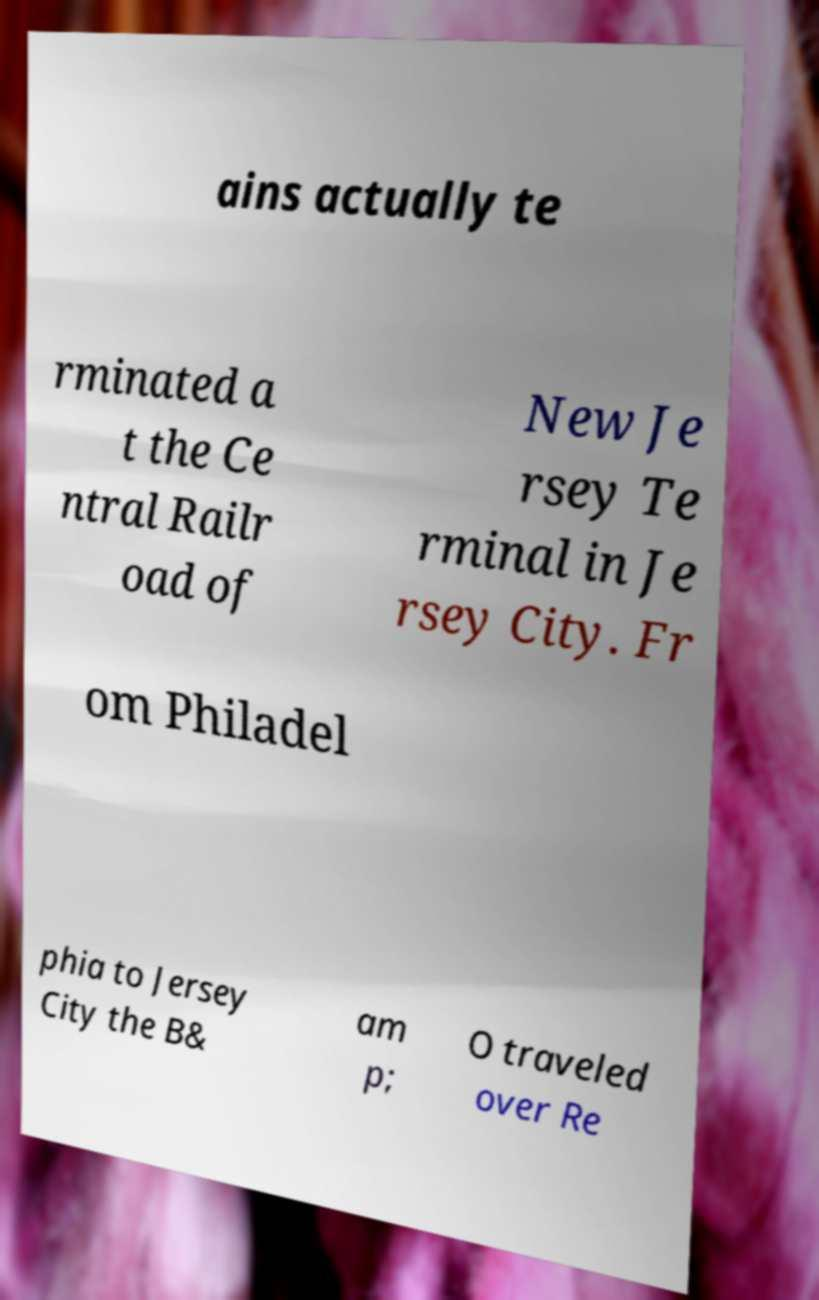What messages or text are displayed in this image? I need them in a readable, typed format. ains actually te rminated a t the Ce ntral Railr oad of New Je rsey Te rminal in Je rsey City. Fr om Philadel phia to Jersey City the B& am p; O traveled over Re 